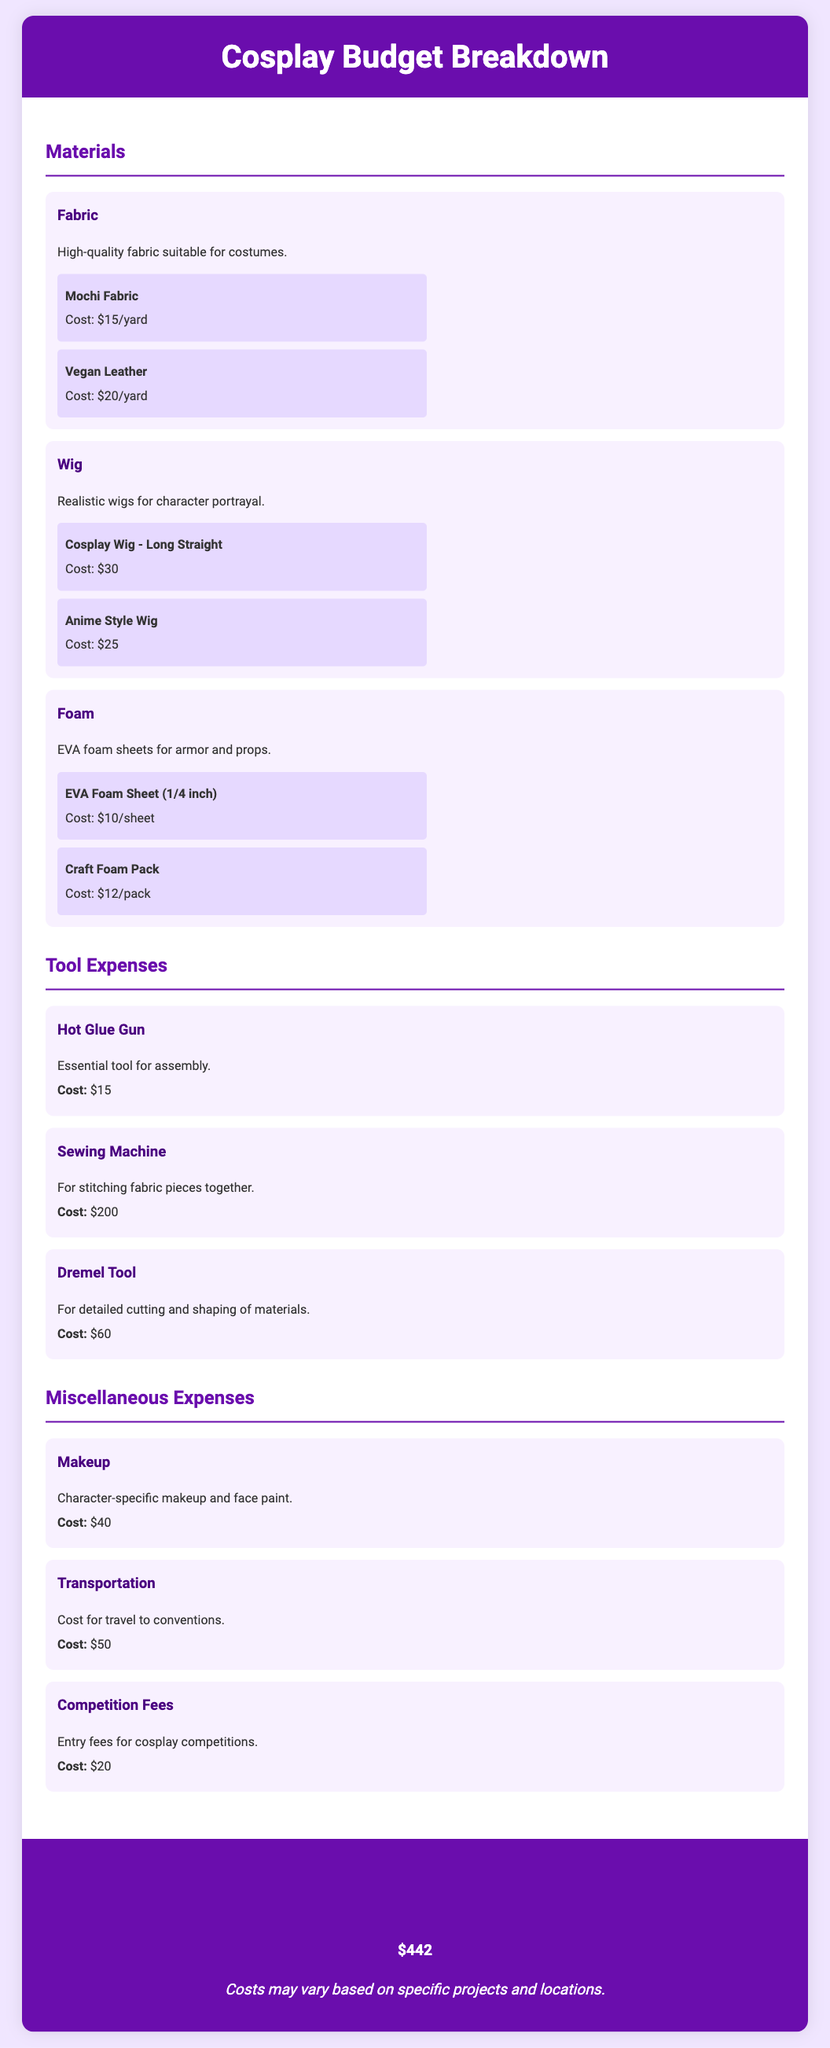What is the cost of Mochi Fabric? Mochi Fabric costs $15 per yard as listed under Materials.
Answer: $15/yard What is the cost of the Sewing Machine? The Sewing Machine is listed under Tool Expenses and costs $200.
Answer: $200 How much does the Anime Style Wig cost? The Anime Style Wig is categorized under Materials and costs $25.
Answer: $25 What is the total estimated cost for the cosplay project? The total estimated cost section summarizes the costs of all items, which is $442.
Answer: $442 What type of tool is a Dremel Tool? The Dremel Tool is mentioned as being important for detailed cutting and shaping of materials in the Tools section.
Answer: Cutting and shaping tool What is the key purpose of the Makeup expense? The Makeup expense is primarily for character-specific makeup and face paint listed under Miscellaneous Expenses.
Answer: Character-specific makeup How many categories are in the document? The document lists Materials, Tool Expenses, and Miscellaneous Expenses as its categorized sections.
Answer: Three What is the cost for competition entry fees? The Competition Fees section specifies the cost for entry fees for cosplay competitions, which is $20.
Answer: $20 What type of fabric is Vegan Leather? Vegan Leather is specified as a type of fabric suitable for costumes under the Materials section.
Answer: Costume fabric 